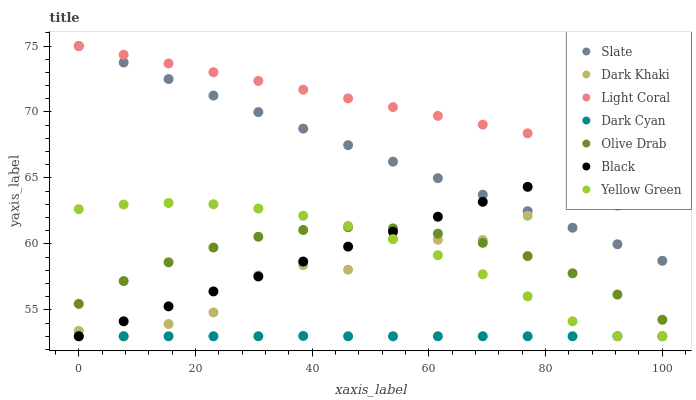Does Dark Cyan have the minimum area under the curve?
Answer yes or no. Yes. Does Light Coral have the maximum area under the curve?
Answer yes or no. Yes. Does Yellow Green have the minimum area under the curve?
Answer yes or no. No. Does Yellow Green have the maximum area under the curve?
Answer yes or no. No. Is Black the smoothest?
Answer yes or no. Yes. Is Dark Khaki the roughest?
Answer yes or no. Yes. Is Yellow Green the smoothest?
Answer yes or no. No. Is Yellow Green the roughest?
Answer yes or no. No. Does Yellow Green have the lowest value?
Answer yes or no. Yes. Does Slate have the lowest value?
Answer yes or no. No. Does Slate have the highest value?
Answer yes or no. Yes. Does Yellow Green have the highest value?
Answer yes or no. No. Is Dark Cyan less than Olive Drab?
Answer yes or no. Yes. Is Slate greater than Dark Cyan?
Answer yes or no. Yes. Does Yellow Green intersect Black?
Answer yes or no. Yes. Is Yellow Green less than Black?
Answer yes or no. No. Is Yellow Green greater than Black?
Answer yes or no. No. Does Dark Cyan intersect Olive Drab?
Answer yes or no. No. 